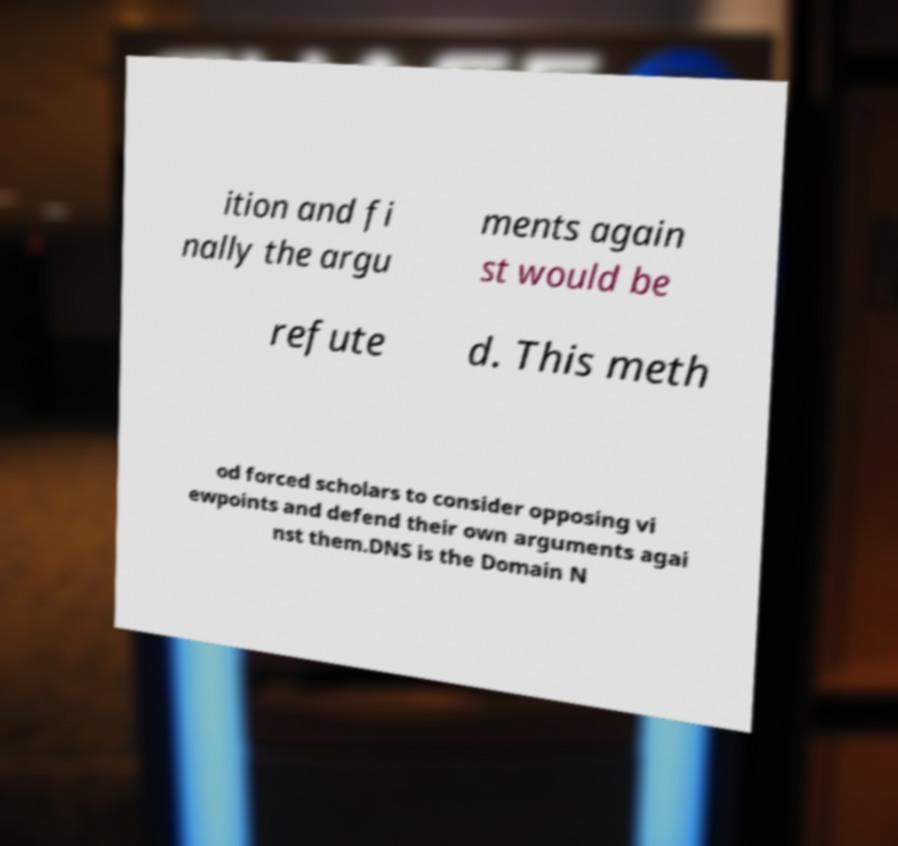What messages or text are displayed in this image? I need them in a readable, typed format. ition and fi nally the argu ments again st would be refute d. This meth od forced scholars to consider opposing vi ewpoints and defend their own arguments agai nst them.DNS is the Domain N 